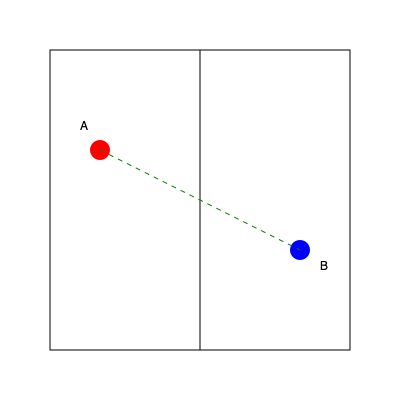In a badminton doubles match, players A and B are positioned as shown in the diagram. Which strategy would provide the most efficient court coverage? To determine the most efficient court coverage strategy, we need to consider the following steps:

1. Analyze player positions:
   - Player A is positioned in the front left quadrant
   - Player B is positioned in the back right quadrant

2. Identify the uncovered areas:
   - The front right and back left quadrants are currently undefended

3. Consider player movement efficiency:
   - The green dashed line represents the diagonal distance between players
   - Moving along this diagonal allows for quicker transitions between front and back court

4. Evaluate strategic options:
   a) Side-by-side formation: Less efficient as it leaves the front or back exposed
   b) Front-back formation: More efficient as it covers both the net and the back court

5. Apply badminton strategy principles:
   - In doubles, one player typically covers the front court while the other covers the back
   - This formation allows for quick interception of both drop shots and clears

6. Conclude the most efficient strategy:
   - Players should maintain their current front-back diagonal formation
   - Player A covers the entire front court (both left and right)
   - Player B covers the entire back court (both left and right)
   - They should be ready to rotate positions based on the opponent's shots

This formation maximizes court coverage while minimizing the distance each player needs to move to reach any part of their designated area.
Answer: Maintain diagonal front-back formation 